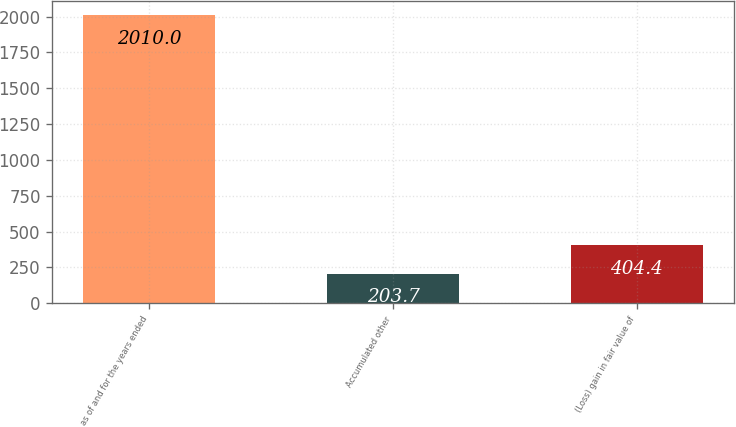<chart> <loc_0><loc_0><loc_500><loc_500><bar_chart><fcel>as of and for the years ended<fcel>Accumulated other<fcel>(Loss) gain in fair value of<nl><fcel>2010<fcel>203.7<fcel>404.4<nl></chart> 